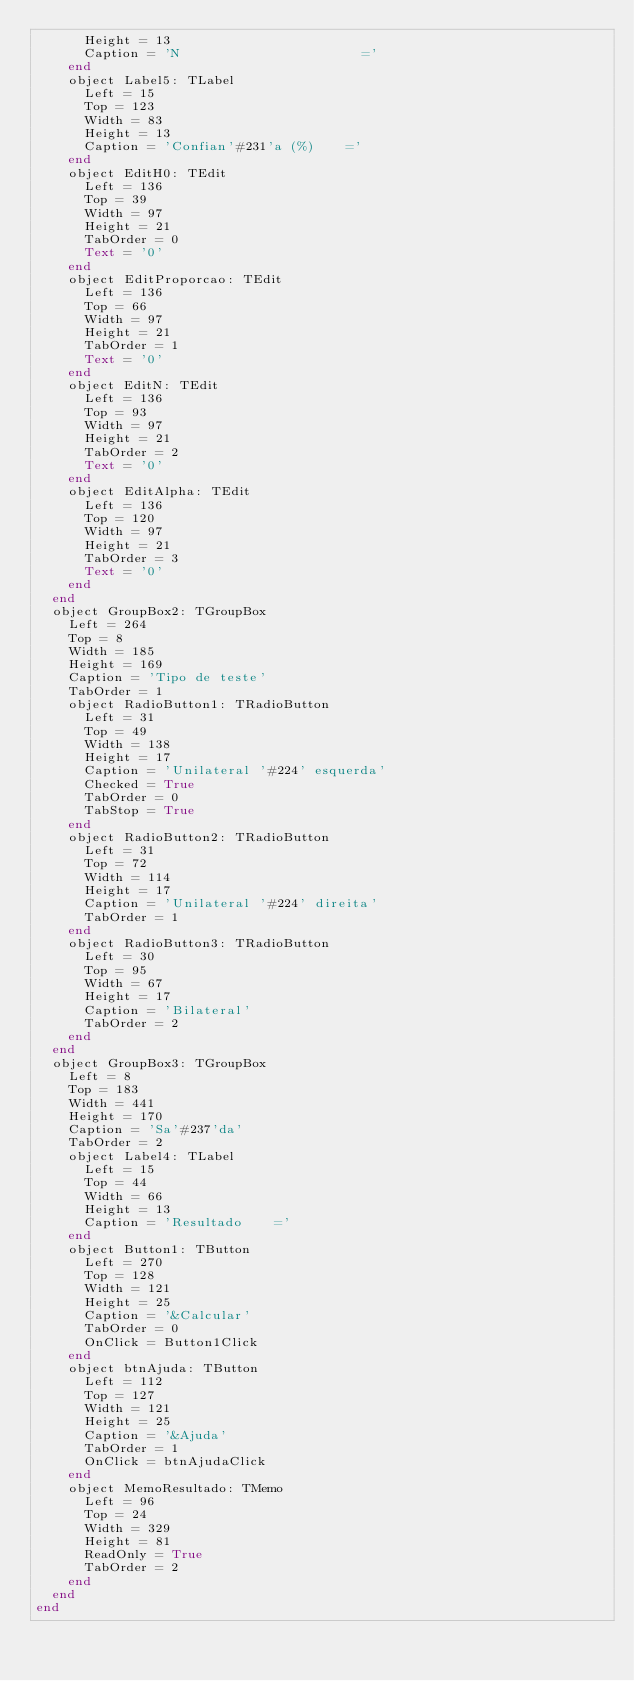<code> <loc_0><loc_0><loc_500><loc_500><_Pascal_>      Height = 13
      Caption = 'N                       ='
    end
    object Label5: TLabel
      Left = 15
      Top = 123
      Width = 83
      Height = 13
      Caption = 'Confian'#231'a (%)    ='
    end
    object EditH0: TEdit
      Left = 136
      Top = 39
      Width = 97
      Height = 21
      TabOrder = 0
      Text = '0'
    end
    object EditProporcao: TEdit
      Left = 136
      Top = 66
      Width = 97
      Height = 21
      TabOrder = 1
      Text = '0'
    end
    object EditN: TEdit
      Left = 136
      Top = 93
      Width = 97
      Height = 21
      TabOrder = 2
      Text = '0'
    end
    object EditAlpha: TEdit
      Left = 136
      Top = 120
      Width = 97
      Height = 21
      TabOrder = 3
      Text = '0'
    end
  end
  object GroupBox2: TGroupBox
    Left = 264
    Top = 8
    Width = 185
    Height = 169
    Caption = 'Tipo de teste'
    TabOrder = 1
    object RadioButton1: TRadioButton
      Left = 31
      Top = 49
      Width = 138
      Height = 17
      Caption = 'Unilateral '#224' esquerda'
      Checked = True
      TabOrder = 0
      TabStop = True
    end
    object RadioButton2: TRadioButton
      Left = 31
      Top = 72
      Width = 114
      Height = 17
      Caption = 'Unilateral '#224' direita'
      TabOrder = 1
    end
    object RadioButton3: TRadioButton
      Left = 30
      Top = 95
      Width = 67
      Height = 17
      Caption = 'Bilateral'
      TabOrder = 2
    end
  end
  object GroupBox3: TGroupBox
    Left = 8
    Top = 183
    Width = 441
    Height = 170
    Caption = 'Sa'#237'da'
    TabOrder = 2
    object Label4: TLabel
      Left = 15
      Top = 44
      Width = 66
      Height = 13
      Caption = 'Resultado    ='
    end
    object Button1: TButton
      Left = 270
      Top = 128
      Width = 121
      Height = 25
      Caption = '&Calcular'
      TabOrder = 0
      OnClick = Button1Click
    end
    object btnAjuda: TButton
      Left = 112
      Top = 127
      Width = 121
      Height = 25
      Caption = '&Ajuda'
      TabOrder = 1
      OnClick = btnAjudaClick
    end
    object MemoResultado: TMemo
      Left = 96
      Top = 24
      Width = 329
      Height = 81
      ReadOnly = True
      TabOrder = 2
    end
  end
end
</code> 